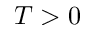Convert formula to latex. <formula><loc_0><loc_0><loc_500><loc_500>T > 0</formula> 